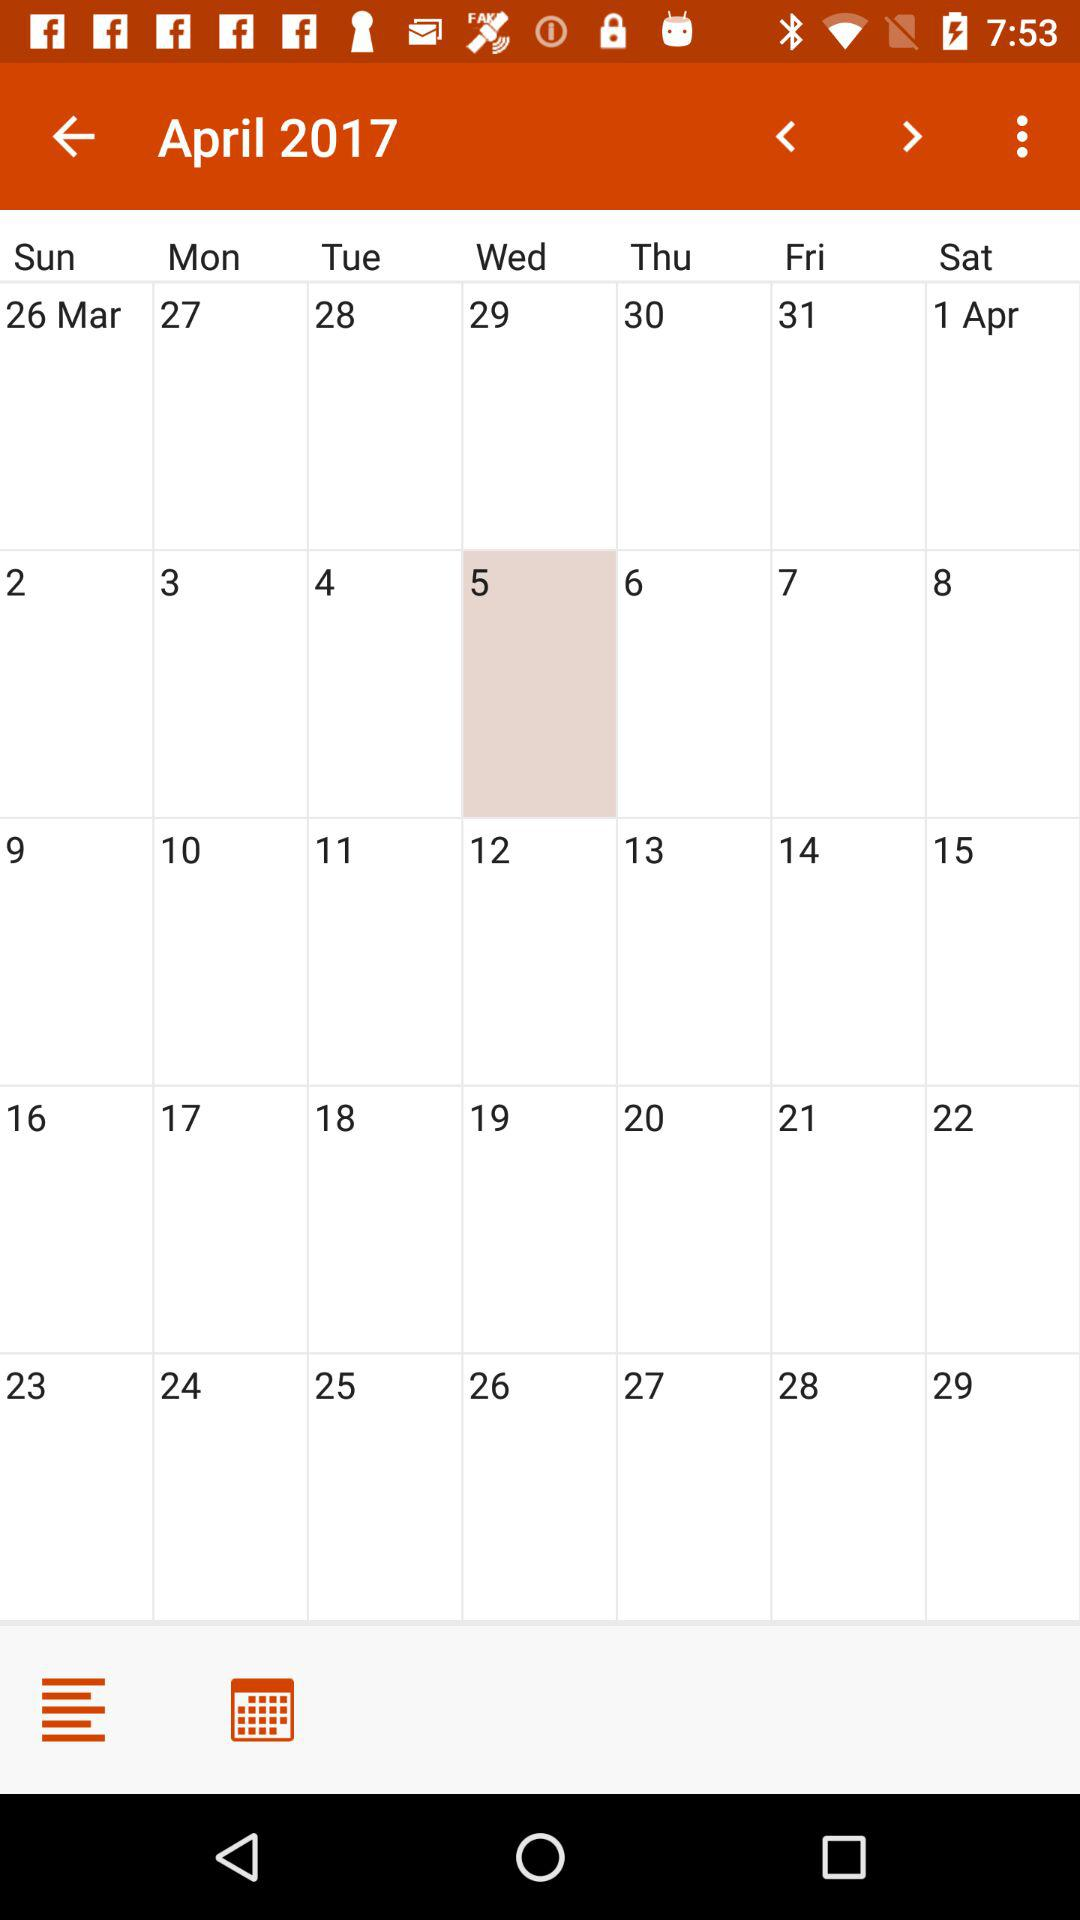Which month is selected in the calendar? The selected month is April. 